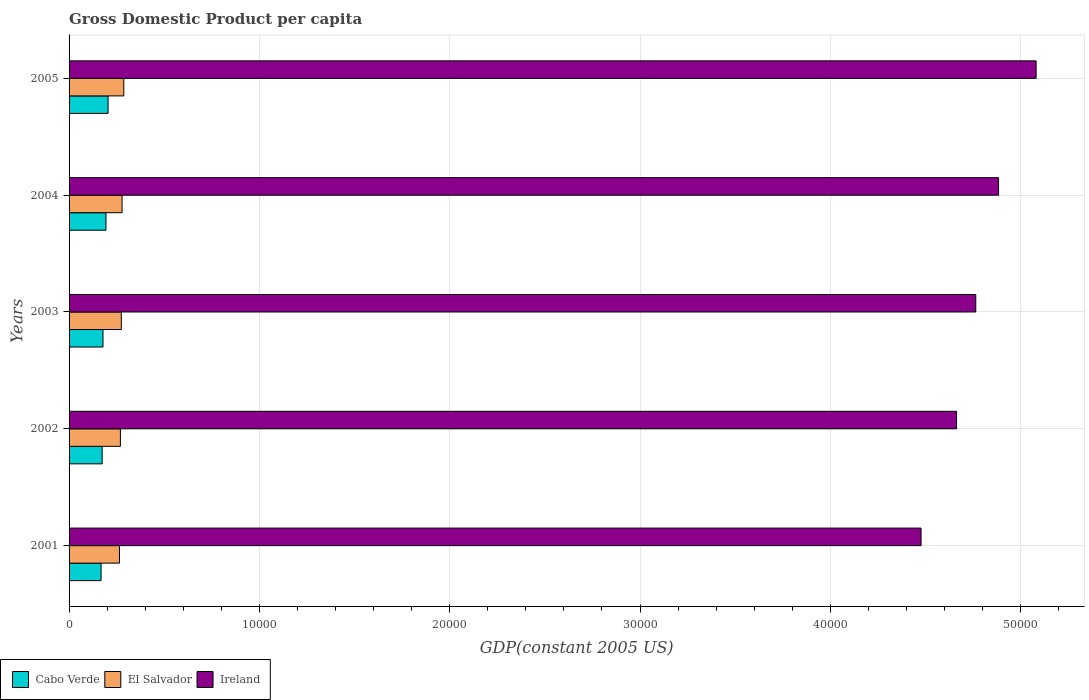How many different coloured bars are there?
Make the answer very short. 3. How many groups of bars are there?
Give a very brief answer. 5. Are the number of bars per tick equal to the number of legend labels?
Make the answer very short. Yes. How many bars are there on the 1st tick from the bottom?
Your answer should be very brief. 3. In how many cases, is the number of bars for a given year not equal to the number of legend labels?
Provide a short and direct response. 0. What is the GDP per capita in El Salvador in 2002?
Give a very brief answer. 2696.74. Across all years, what is the maximum GDP per capita in El Salvador?
Your response must be concise. 2874.26. Across all years, what is the minimum GDP per capita in El Salvador?
Your answer should be compact. 2648.39. In which year was the GDP per capita in Ireland maximum?
Your answer should be very brief. 2005. What is the total GDP per capita in Ireland in the graph?
Give a very brief answer. 2.39e+05. What is the difference between the GDP per capita in El Salvador in 2001 and that in 2005?
Provide a short and direct response. -225.87. What is the difference between the GDP per capita in Cabo Verde in 2005 and the GDP per capita in El Salvador in 2002?
Your answer should be compact. -647.13. What is the average GDP per capita in Cabo Verde per year?
Give a very brief answer. 1838.44. In the year 2001, what is the difference between the GDP per capita in Cabo Verde and GDP per capita in Ireland?
Your response must be concise. -4.31e+04. In how many years, is the GDP per capita in El Salvador greater than 50000 US$?
Your response must be concise. 0. What is the ratio of the GDP per capita in El Salvador in 2001 to that in 2005?
Offer a terse response. 0.92. Is the GDP per capita in Cabo Verde in 2001 less than that in 2005?
Give a very brief answer. Yes. What is the difference between the highest and the second highest GDP per capita in Ireland?
Offer a terse response. 1974.4. What is the difference between the highest and the lowest GDP per capita in Cabo Verde?
Provide a short and direct response. 367.68. What does the 3rd bar from the top in 2005 represents?
Provide a short and direct response. Cabo Verde. What does the 1st bar from the bottom in 2003 represents?
Your response must be concise. Cabo Verde. What is the difference between two consecutive major ticks on the X-axis?
Your response must be concise. 10000. Are the values on the major ticks of X-axis written in scientific E-notation?
Ensure brevity in your answer.  No. Does the graph contain any zero values?
Ensure brevity in your answer.  No. Does the graph contain grids?
Your answer should be compact. Yes. Where does the legend appear in the graph?
Ensure brevity in your answer.  Bottom left. What is the title of the graph?
Make the answer very short. Gross Domestic Product per capita. Does "Papua New Guinea" appear as one of the legend labels in the graph?
Your answer should be compact. No. What is the label or title of the X-axis?
Ensure brevity in your answer.  GDP(constant 2005 US). What is the label or title of the Y-axis?
Provide a short and direct response. Years. What is the GDP(constant 2005 US) in Cabo Verde in 2001?
Give a very brief answer. 1681.93. What is the GDP(constant 2005 US) in El Salvador in 2001?
Provide a succinct answer. 2648.39. What is the GDP(constant 2005 US) of Ireland in 2001?
Offer a terse response. 4.48e+04. What is the GDP(constant 2005 US) in Cabo Verde in 2002?
Ensure brevity in your answer.  1739. What is the GDP(constant 2005 US) in El Salvador in 2002?
Give a very brief answer. 2696.74. What is the GDP(constant 2005 US) in Ireland in 2002?
Keep it short and to the point. 4.66e+04. What is the GDP(constant 2005 US) in Cabo Verde in 2003?
Your answer should be very brief. 1783.12. What is the GDP(constant 2005 US) of El Salvador in 2003?
Provide a short and direct response. 2746.32. What is the GDP(constant 2005 US) of Ireland in 2003?
Offer a very short reply. 4.76e+04. What is the GDP(constant 2005 US) of Cabo Verde in 2004?
Keep it short and to the point. 1938.51. What is the GDP(constant 2005 US) of El Salvador in 2004?
Provide a succinct answer. 2785.74. What is the GDP(constant 2005 US) in Ireland in 2004?
Keep it short and to the point. 4.88e+04. What is the GDP(constant 2005 US) of Cabo Verde in 2005?
Offer a very short reply. 2049.62. What is the GDP(constant 2005 US) in El Salvador in 2005?
Offer a terse response. 2874.26. What is the GDP(constant 2005 US) in Ireland in 2005?
Provide a short and direct response. 5.08e+04. Across all years, what is the maximum GDP(constant 2005 US) of Cabo Verde?
Offer a terse response. 2049.62. Across all years, what is the maximum GDP(constant 2005 US) of El Salvador?
Offer a very short reply. 2874.26. Across all years, what is the maximum GDP(constant 2005 US) in Ireland?
Make the answer very short. 5.08e+04. Across all years, what is the minimum GDP(constant 2005 US) in Cabo Verde?
Make the answer very short. 1681.93. Across all years, what is the minimum GDP(constant 2005 US) of El Salvador?
Make the answer very short. 2648.39. Across all years, what is the minimum GDP(constant 2005 US) in Ireland?
Your response must be concise. 4.48e+04. What is the total GDP(constant 2005 US) in Cabo Verde in the graph?
Make the answer very short. 9192.19. What is the total GDP(constant 2005 US) in El Salvador in the graph?
Make the answer very short. 1.38e+04. What is the total GDP(constant 2005 US) of Ireland in the graph?
Ensure brevity in your answer.  2.39e+05. What is the difference between the GDP(constant 2005 US) in Cabo Verde in 2001 and that in 2002?
Make the answer very short. -57.07. What is the difference between the GDP(constant 2005 US) in El Salvador in 2001 and that in 2002?
Your response must be concise. -48.35. What is the difference between the GDP(constant 2005 US) in Ireland in 2001 and that in 2002?
Give a very brief answer. -1865.28. What is the difference between the GDP(constant 2005 US) of Cabo Verde in 2001 and that in 2003?
Provide a short and direct response. -101.19. What is the difference between the GDP(constant 2005 US) of El Salvador in 2001 and that in 2003?
Your answer should be compact. -97.93. What is the difference between the GDP(constant 2005 US) in Ireland in 2001 and that in 2003?
Keep it short and to the point. -2874.61. What is the difference between the GDP(constant 2005 US) in Cabo Verde in 2001 and that in 2004?
Provide a short and direct response. -256.58. What is the difference between the GDP(constant 2005 US) in El Salvador in 2001 and that in 2004?
Offer a terse response. -137.35. What is the difference between the GDP(constant 2005 US) in Ireland in 2001 and that in 2004?
Offer a very short reply. -4072.2. What is the difference between the GDP(constant 2005 US) of Cabo Verde in 2001 and that in 2005?
Keep it short and to the point. -367.68. What is the difference between the GDP(constant 2005 US) in El Salvador in 2001 and that in 2005?
Make the answer very short. -225.87. What is the difference between the GDP(constant 2005 US) of Ireland in 2001 and that in 2005?
Make the answer very short. -6046.59. What is the difference between the GDP(constant 2005 US) in Cabo Verde in 2002 and that in 2003?
Keep it short and to the point. -44.12. What is the difference between the GDP(constant 2005 US) in El Salvador in 2002 and that in 2003?
Provide a succinct answer. -49.58. What is the difference between the GDP(constant 2005 US) in Ireland in 2002 and that in 2003?
Offer a terse response. -1009.34. What is the difference between the GDP(constant 2005 US) of Cabo Verde in 2002 and that in 2004?
Ensure brevity in your answer.  -199.51. What is the difference between the GDP(constant 2005 US) of El Salvador in 2002 and that in 2004?
Ensure brevity in your answer.  -88.99. What is the difference between the GDP(constant 2005 US) of Ireland in 2002 and that in 2004?
Make the answer very short. -2206.92. What is the difference between the GDP(constant 2005 US) in Cabo Verde in 2002 and that in 2005?
Provide a succinct answer. -310.62. What is the difference between the GDP(constant 2005 US) of El Salvador in 2002 and that in 2005?
Provide a succinct answer. -177.51. What is the difference between the GDP(constant 2005 US) of Ireland in 2002 and that in 2005?
Provide a succinct answer. -4181.31. What is the difference between the GDP(constant 2005 US) of Cabo Verde in 2003 and that in 2004?
Keep it short and to the point. -155.39. What is the difference between the GDP(constant 2005 US) in El Salvador in 2003 and that in 2004?
Offer a terse response. -39.42. What is the difference between the GDP(constant 2005 US) of Ireland in 2003 and that in 2004?
Give a very brief answer. -1197.58. What is the difference between the GDP(constant 2005 US) in Cabo Verde in 2003 and that in 2005?
Make the answer very short. -266.49. What is the difference between the GDP(constant 2005 US) of El Salvador in 2003 and that in 2005?
Keep it short and to the point. -127.94. What is the difference between the GDP(constant 2005 US) in Ireland in 2003 and that in 2005?
Provide a short and direct response. -3171.98. What is the difference between the GDP(constant 2005 US) in Cabo Verde in 2004 and that in 2005?
Give a very brief answer. -111.1. What is the difference between the GDP(constant 2005 US) in El Salvador in 2004 and that in 2005?
Offer a terse response. -88.52. What is the difference between the GDP(constant 2005 US) in Ireland in 2004 and that in 2005?
Offer a very short reply. -1974.4. What is the difference between the GDP(constant 2005 US) of Cabo Verde in 2001 and the GDP(constant 2005 US) of El Salvador in 2002?
Ensure brevity in your answer.  -1014.81. What is the difference between the GDP(constant 2005 US) of Cabo Verde in 2001 and the GDP(constant 2005 US) of Ireland in 2002?
Your answer should be very brief. -4.50e+04. What is the difference between the GDP(constant 2005 US) of El Salvador in 2001 and the GDP(constant 2005 US) of Ireland in 2002?
Your answer should be compact. -4.40e+04. What is the difference between the GDP(constant 2005 US) in Cabo Verde in 2001 and the GDP(constant 2005 US) in El Salvador in 2003?
Make the answer very short. -1064.39. What is the difference between the GDP(constant 2005 US) of Cabo Verde in 2001 and the GDP(constant 2005 US) of Ireland in 2003?
Offer a terse response. -4.60e+04. What is the difference between the GDP(constant 2005 US) in El Salvador in 2001 and the GDP(constant 2005 US) in Ireland in 2003?
Offer a terse response. -4.50e+04. What is the difference between the GDP(constant 2005 US) of Cabo Verde in 2001 and the GDP(constant 2005 US) of El Salvador in 2004?
Offer a very short reply. -1103.8. What is the difference between the GDP(constant 2005 US) of Cabo Verde in 2001 and the GDP(constant 2005 US) of Ireland in 2004?
Your answer should be very brief. -4.72e+04. What is the difference between the GDP(constant 2005 US) in El Salvador in 2001 and the GDP(constant 2005 US) in Ireland in 2004?
Ensure brevity in your answer.  -4.62e+04. What is the difference between the GDP(constant 2005 US) of Cabo Verde in 2001 and the GDP(constant 2005 US) of El Salvador in 2005?
Keep it short and to the point. -1192.32. What is the difference between the GDP(constant 2005 US) of Cabo Verde in 2001 and the GDP(constant 2005 US) of Ireland in 2005?
Your answer should be compact. -4.91e+04. What is the difference between the GDP(constant 2005 US) of El Salvador in 2001 and the GDP(constant 2005 US) of Ireland in 2005?
Your answer should be compact. -4.82e+04. What is the difference between the GDP(constant 2005 US) in Cabo Verde in 2002 and the GDP(constant 2005 US) in El Salvador in 2003?
Ensure brevity in your answer.  -1007.32. What is the difference between the GDP(constant 2005 US) in Cabo Verde in 2002 and the GDP(constant 2005 US) in Ireland in 2003?
Make the answer very short. -4.59e+04. What is the difference between the GDP(constant 2005 US) in El Salvador in 2002 and the GDP(constant 2005 US) in Ireland in 2003?
Your answer should be compact. -4.49e+04. What is the difference between the GDP(constant 2005 US) in Cabo Verde in 2002 and the GDP(constant 2005 US) in El Salvador in 2004?
Provide a short and direct response. -1046.74. What is the difference between the GDP(constant 2005 US) of Cabo Verde in 2002 and the GDP(constant 2005 US) of Ireland in 2004?
Provide a short and direct response. -4.71e+04. What is the difference between the GDP(constant 2005 US) of El Salvador in 2002 and the GDP(constant 2005 US) of Ireland in 2004?
Your response must be concise. -4.61e+04. What is the difference between the GDP(constant 2005 US) of Cabo Verde in 2002 and the GDP(constant 2005 US) of El Salvador in 2005?
Offer a very short reply. -1135.26. What is the difference between the GDP(constant 2005 US) of Cabo Verde in 2002 and the GDP(constant 2005 US) of Ireland in 2005?
Provide a short and direct response. -4.91e+04. What is the difference between the GDP(constant 2005 US) of El Salvador in 2002 and the GDP(constant 2005 US) of Ireland in 2005?
Provide a short and direct response. -4.81e+04. What is the difference between the GDP(constant 2005 US) in Cabo Verde in 2003 and the GDP(constant 2005 US) in El Salvador in 2004?
Make the answer very short. -1002.61. What is the difference between the GDP(constant 2005 US) in Cabo Verde in 2003 and the GDP(constant 2005 US) in Ireland in 2004?
Your answer should be compact. -4.71e+04. What is the difference between the GDP(constant 2005 US) in El Salvador in 2003 and the GDP(constant 2005 US) in Ireland in 2004?
Your answer should be compact. -4.61e+04. What is the difference between the GDP(constant 2005 US) in Cabo Verde in 2003 and the GDP(constant 2005 US) in El Salvador in 2005?
Offer a terse response. -1091.13. What is the difference between the GDP(constant 2005 US) in Cabo Verde in 2003 and the GDP(constant 2005 US) in Ireland in 2005?
Provide a short and direct response. -4.90e+04. What is the difference between the GDP(constant 2005 US) of El Salvador in 2003 and the GDP(constant 2005 US) of Ireland in 2005?
Ensure brevity in your answer.  -4.81e+04. What is the difference between the GDP(constant 2005 US) of Cabo Verde in 2004 and the GDP(constant 2005 US) of El Salvador in 2005?
Offer a terse response. -935.74. What is the difference between the GDP(constant 2005 US) of Cabo Verde in 2004 and the GDP(constant 2005 US) of Ireland in 2005?
Your answer should be very brief. -4.89e+04. What is the difference between the GDP(constant 2005 US) of El Salvador in 2004 and the GDP(constant 2005 US) of Ireland in 2005?
Ensure brevity in your answer.  -4.80e+04. What is the average GDP(constant 2005 US) of Cabo Verde per year?
Your answer should be very brief. 1838.44. What is the average GDP(constant 2005 US) in El Salvador per year?
Give a very brief answer. 2750.29. What is the average GDP(constant 2005 US) in Ireland per year?
Your response must be concise. 4.77e+04. In the year 2001, what is the difference between the GDP(constant 2005 US) of Cabo Verde and GDP(constant 2005 US) of El Salvador?
Give a very brief answer. -966.46. In the year 2001, what is the difference between the GDP(constant 2005 US) in Cabo Verde and GDP(constant 2005 US) in Ireland?
Your answer should be compact. -4.31e+04. In the year 2001, what is the difference between the GDP(constant 2005 US) in El Salvador and GDP(constant 2005 US) in Ireland?
Provide a succinct answer. -4.21e+04. In the year 2002, what is the difference between the GDP(constant 2005 US) of Cabo Verde and GDP(constant 2005 US) of El Salvador?
Keep it short and to the point. -957.74. In the year 2002, what is the difference between the GDP(constant 2005 US) of Cabo Verde and GDP(constant 2005 US) of Ireland?
Offer a very short reply. -4.49e+04. In the year 2002, what is the difference between the GDP(constant 2005 US) in El Salvador and GDP(constant 2005 US) in Ireland?
Your answer should be very brief. -4.39e+04. In the year 2003, what is the difference between the GDP(constant 2005 US) of Cabo Verde and GDP(constant 2005 US) of El Salvador?
Your answer should be very brief. -963.2. In the year 2003, what is the difference between the GDP(constant 2005 US) in Cabo Verde and GDP(constant 2005 US) in Ireland?
Your answer should be compact. -4.59e+04. In the year 2003, what is the difference between the GDP(constant 2005 US) in El Salvador and GDP(constant 2005 US) in Ireland?
Offer a very short reply. -4.49e+04. In the year 2004, what is the difference between the GDP(constant 2005 US) of Cabo Verde and GDP(constant 2005 US) of El Salvador?
Provide a succinct answer. -847.22. In the year 2004, what is the difference between the GDP(constant 2005 US) in Cabo Verde and GDP(constant 2005 US) in Ireland?
Make the answer very short. -4.69e+04. In the year 2004, what is the difference between the GDP(constant 2005 US) of El Salvador and GDP(constant 2005 US) of Ireland?
Your answer should be compact. -4.61e+04. In the year 2005, what is the difference between the GDP(constant 2005 US) of Cabo Verde and GDP(constant 2005 US) of El Salvador?
Give a very brief answer. -824.64. In the year 2005, what is the difference between the GDP(constant 2005 US) of Cabo Verde and GDP(constant 2005 US) of Ireland?
Keep it short and to the point. -4.88e+04. In the year 2005, what is the difference between the GDP(constant 2005 US) of El Salvador and GDP(constant 2005 US) of Ireland?
Provide a short and direct response. -4.79e+04. What is the ratio of the GDP(constant 2005 US) of Cabo Verde in 2001 to that in 2002?
Your response must be concise. 0.97. What is the ratio of the GDP(constant 2005 US) of El Salvador in 2001 to that in 2002?
Provide a succinct answer. 0.98. What is the ratio of the GDP(constant 2005 US) in Ireland in 2001 to that in 2002?
Your answer should be very brief. 0.96. What is the ratio of the GDP(constant 2005 US) in Cabo Verde in 2001 to that in 2003?
Ensure brevity in your answer.  0.94. What is the ratio of the GDP(constant 2005 US) in El Salvador in 2001 to that in 2003?
Your response must be concise. 0.96. What is the ratio of the GDP(constant 2005 US) in Ireland in 2001 to that in 2003?
Offer a very short reply. 0.94. What is the ratio of the GDP(constant 2005 US) in Cabo Verde in 2001 to that in 2004?
Your answer should be compact. 0.87. What is the ratio of the GDP(constant 2005 US) in El Salvador in 2001 to that in 2004?
Your response must be concise. 0.95. What is the ratio of the GDP(constant 2005 US) of Ireland in 2001 to that in 2004?
Your answer should be very brief. 0.92. What is the ratio of the GDP(constant 2005 US) of Cabo Verde in 2001 to that in 2005?
Provide a succinct answer. 0.82. What is the ratio of the GDP(constant 2005 US) of El Salvador in 2001 to that in 2005?
Offer a very short reply. 0.92. What is the ratio of the GDP(constant 2005 US) of Ireland in 2001 to that in 2005?
Your response must be concise. 0.88. What is the ratio of the GDP(constant 2005 US) of Cabo Verde in 2002 to that in 2003?
Give a very brief answer. 0.98. What is the ratio of the GDP(constant 2005 US) of El Salvador in 2002 to that in 2003?
Give a very brief answer. 0.98. What is the ratio of the GDP(constant 2005 US) of Ireland in 2002 to that in 2003?
Offer a terse response. 0.98. What is the ratio of the GDP(constant 2005 US) in Cabo Verde in 2002 to that in 2004?
Ensure brevity in your answer.  0.9. What is the ratio of the GDP(constant 2005 US) of El Salvador in 2002 to that in 2004?
Provide a short and direct response. 0.97. What is the ratio of the GDP(constant 2005 US) in Ireland in 2002 to that in 2004?
Provide a succinct answer. 0.95. What is the ratio of the GDP(constant 2005 US) in Cabo Verde in 2002 to that in 2005?
Your answer should be compact. 0.85. What is the ratio of the GDP(constant 2005 US) in El Salvador in 2002 to that in 2005?
Make the answer very short. 0.94. What is the ratio of the GDP(constant 2005 US) in Ireland in 2002 to that in 2005?
Make the answer very short. 0.92. What is the ratio of the GDP(constant 2005 US) of Cabo Verde in 2003 to that in 2004?
Offer a very short reply. 0.92. What is the ratio of the GDP(constant 2005 US) in El Salvador in 2003 to that in 2004?
Keep it short and to the point. 0.99. What is the ratio of the GDP(constant 2005 US) of Ireland in 2003 to that in 2004?
Give a very brief answer. 0.98. What is the ratio of the GDP(constant 2005 US) of Cabo Verde in 2003 to that in 2005?
Make the answer very short. 0.87. What is the ratio of the GDP(constant 2005 US) of El Salvador in 2003 to that in 2005?
Provide a succinct answer. 0.96. What is the ratio of the GDP(constant 2005 US) of Ireland in 2003 to that in 2005?
Your response must be concise. 0.94. What is the ratio of the GDP(constant 2005 US) in Cabo Verde in 2004 to that in 2005?
Provide a short and direct response. 0.95. What is the ratio of the GDP(constant 2005 US) of El Salvador in 2004 to that in 2005?
Ensure brevity in your answer.  0.97. What is the ratio of the GDP(constant 2005 US) of Ireland in 2004 to that in 2005?
Make the answer very short. 0.96. What is the difference between the highest and the second highest GDP(constant 2005 US) of Cabo Verde?
Provide a succinct answer. 111.1. What is the difference between the highest and the second highest GDP(constant 2005 US) in El Salvador?
Ensure brevity in your answer.  88.52. What is the difference between the highest and the second highest GDP(constant 2005 US) of Ireland?
Your response must be concise. 1974.4. What is the difference between the highest and the lowest GDP(constant 2005 US) of Cabo Verde?
Provide a succinct answer. 367.68. What is the difference between the highest and the lowest GDP(constant 2005 US) of El Salvador?
Keep it short and to the point. 225.87. What is the difference between the highest and the lowest GDP(constant 2005 US) in Ireland?
Offer a very short reply. 6046.59. 